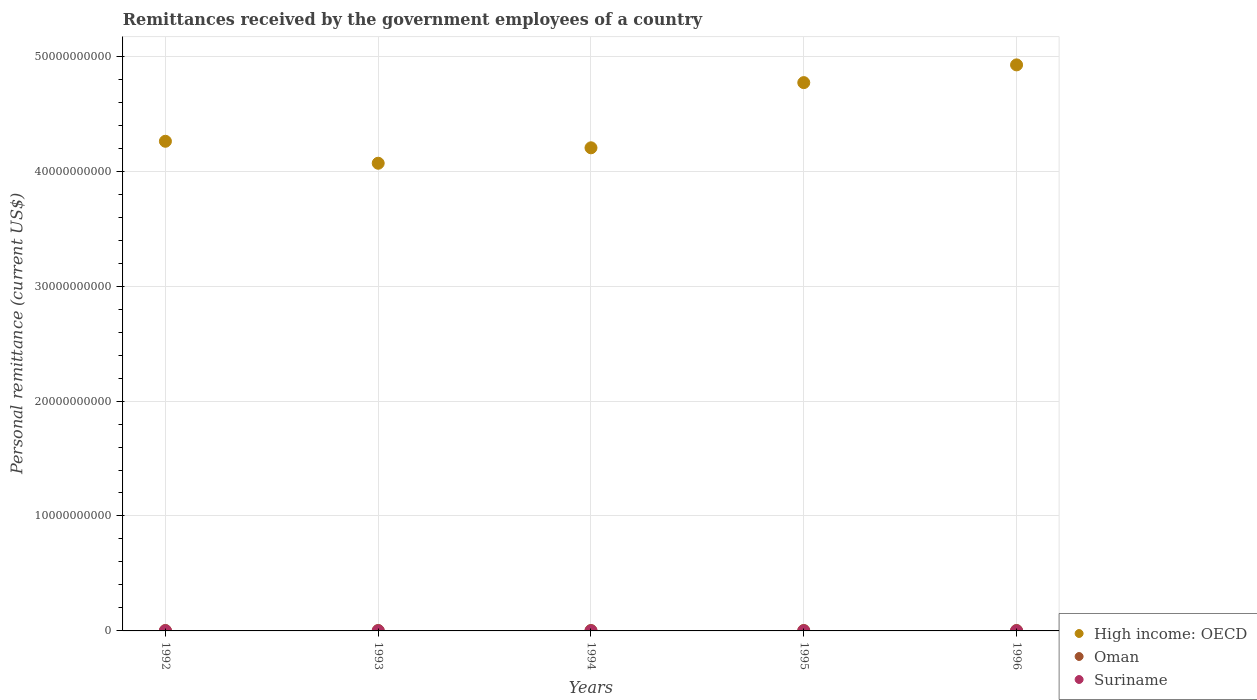Is the number of dotlines equal to the number of legend labels?
Give a very brief answer. Yes. What is the remittances received by the government employees in Suriname in 1993?
Offer a very short reply. 3.50e+06. Across all years, what is the maximum remittances received by the government employees in Oman?
Your answer should be very brief. 3.90e+07. Across all years, what is the minimum remittances received by the government employees in Oman?
Make the answer very short. 3.90e+07. What is the total remittances received by the government employees in Oman in the graph?
Your answer should be compact. 1.95e+08. What is the difference between the remittances received by the government employees in Suriname in 1992 and that in 1996?
Provide a short and direct response. 4.27e+06. What is the difference between the remittances received by the government employees in High income: OECD in 1992 and the remittances received by the government employees in Suriname in 1995?
Offer a very short reply. 4.26e+1. What is the average remittances received by the government employees in Suriname per year?
Provide a short and direct response. 1.78e+06. In the year 1994, what is the difference between the remittances received by the government employees in Oman and remittances received by the government employees in High income: OECD?
Keep it short and to the point. -4.20e+1. What is the ratio of the remittances received by the government employees in High income: OECD in 1993 to that in 1994?
Your answer should be compact. 0.97. Is the remittances received by the government employees in High income: OECD in 1994 less than that in 1995?
Provide a short and direct response. Yes. Is the difference between the remittances received by the government employees in Oman in 1994 and 1996 greater than the difference between the remittances received by the government employees in High income: OECD in 1994 and 1996?
Offer a very short reply. Yes. What is the difference between the highest and the second highest remittances received by the government employees in Suriname?
Provide a succinct answer. 1.10e+06. What is the difference between the highest and the lowest remittances received by the government employees in Oman?
Your response must be concise. 1.17e+04. In how many years, is the remittances received by the government employees in Oman greater than the average remittances received by the government employees in Oman taken over all years?
Provide a succinct answer. 4. Is the sum of the remittances received by the government employees in Oman in 1992 and 1993 greater than the maximum remittances received by the government employees in Suriname across all years?
Offer a terse response. Yes. Does the graph contain grids?
Your response must be concise. Yes. How many legend labels are there?
Make the answer very short. 3. How are the legend labels stacked?
Provide a short and direct response. Vertical. What is the title of the graph?
Your answer should be very brief. Remittances received by the government employees of a country. Does "Montenegro" appear as one of the legend labels in the graph?
Give a very brief answer. No. What is the label or title of the Y-axis?
Give a very brief answer. Personal remittance (current US$). What is the Personal remittance (current US$) in High income: OECD in 1992?
Give a very brief answer. 4.26e+1. What is the Personal remittance (current US$) of Oman in 1992?
Offer a terse response. 3.90e+07. What is the Personal remittance (current US$) of Suriname in 1992?
Your answer should be compact. 4.60e+06. What is the Personal remittance (current US$) in High income: OECD in 1993?
Give a very brief answer. 4.07e+1. What is the Personal remittance (current US$) of Oman in 1993?
Provide a short and direct response. 3.90e+07. What is the Personal remittance (current US$) in Suriname in 1993?
Your response must be concise. 3.50e+06. What is the Personal remittance (current US$) in High income: OECD in 1994?
Your response must be concise. 4.20e+1. What is the Personal remittance (current US$) of Oman in 1994?
Ensure brevity in your answer.  3.90e+07. What is the Personal remittance (current US$) of Suriname in 1994?
Keep it short and to the point. 2.00e+05. What is the Personal remittance (current US$) of High income: OECD in 1995?
Make the answer very short. 4.77e+1. What is the Personal remittance (current US$) of Oman in 1995?
Keep it short and to the point. 3.90e+07. What is the Personal remittance (current US$) in Suriname in 1995?
Ensure brevity in your answer.  2.67e+05. What is the Personal remittance (current US$) of High income: OECD in 1996?
Offer a very short reply. 4.92e+1. What is the Personal remittance (current US$) in Oman in 1996?
Provide a succinct answer. 3.90e+07. What is the Personal remittance (current US$) in Suriname in 1996?
Your answer should be compact. 3.33e+05. Across all years, what is the maximum Personal remittance (current US$) of High income: OECD?
Offer a very short reply. 4.92e+1. Across all years, what is the maximum Personal remittance (current US$) in Oman?
Your answer should be compact. 3.90e+07. Across all years, what is the maximum Personal remittance (current US$) in Suriname?
Provide a short and direct response. 4.60e+06. Across all years, what is the minimum Personal remittance (current US$) in High income: OECD?
Offer a terse response. 4.07e+1. Across all years, what is the minimum Personal remittance (current US$) in Oman?
Your response must be concise. 3.90e+07. Across all years, what is the minimum Personal remittance (current US$) in Suriname?
Offer a very short reply. 2.00e+05. What is the total Personal remittance (current US$) in High income: OECD in the graph?
Give a very brief answer. 2.22e+11. What is the total Personal remittance (current US$) of Oman in the graph?
Provide a short and direct response. 1.95e+08. What is the total Personal remittance (current US$) in Suriname in the graph?
Offer a terse response. 8.90e+06. What is the difference between the Personal remittance (current US$) in High income: OECD in 1992 and that in 1993?
Give a very brief answer. 1.91e+09. What is the difference between the Personal remittance (current US$) in Suriname in 1992 and that in 1993?
Your answer should be very brief. 1.10e+06. What is the difference between the Personal remittance (current US$) in High income: OECD in 1992 and that in 1994?
Ensure brevity in your answer.  5.69e+08. What is the difference between the Personal remittance (current US$) of Oman in 1992 and that in 1994?
Ensure brevity in your answer.  0. What is the difference between the Personal remittance (current US$) of Suriname in 1992 and that in 1994?
Provide a succinct answer. 4.40e+06. What is the difference between the Personal remittance (current US$) in High income: OECD in 1992 and that in 1995?
Keep it short and to the point. -5.10e+09. What is the difference between the Personal remittance (current US$) in Oman in 1992 and that in 1995?
Give a very brief answer. 0. What is the difference between the Personal remittance (current US$) in Suriname in 1992 and that in 1995?
Your answer should be very brief. 4.33e+06. What is the difference between the Personal remittance (current US$) of High income: OECD in 1992 and that in 1996?
Your response must be concise. -6.65e+09. What is the difference between the Personal remittance (current US$) in Oman in 1992 and that in 1996?
Provide a short and direct response. 1.17e+04. What is the difference between the Personal remittance (current US$) in Suriname in 1992 and that in 1996?
Keep it short and to the point. 4.27e+06. What is the difference between the Personal remittance (current US$) of High income: OECD in 1993 and that in 1994?
Your answer should be compact. -1.34e+09. What is the difference between the Personal remittance (current US$) in Suriname in 1993 and that in 1994?
Provide a succinct answer. 3.30e+06. What is the difference between the Personal remittance (current US$) in High income: OECD in 1993 and that in 1995?
Provide a succinct answer. -7.01e+09. What is the difference between the Personal remittance (current US$) in Suriname in 1993 and that in 1995?
Ensure brevity in your answer.  3.23e+06. What is the difference between the Personal remittance (current US$) of High income: OECD in 1993 and that in 1996?
Keep it short and to the point. -8.56e+09. What is the difference between the Personal remittance (current US$) of Oman in 1993 and that in 1996?
Your response must be concise. 1.17e+04. What is the difference between the Personal remittance (current US$) of Suriname in 1993 and that in 1996?
Provide a short and direct response. 3.17e+06. What is the difference between the Personal remittance (current US$) in High income: OECD in 1994 and that in 1995?
Ensure brevity in your answer.  -5.67e+09. What is the difference between the Personal remittance (current US$) of Oman in 1994 and that in 1995?
Offer a terse response. 0. What is the difference between the Personal remittance (current US$) in Suriname in 1994 and that in 1995?
Your answer should be very brief. -6.67e+04. What is the difference between the Personal remittance (current US$) in High income: OECD in 1994 and that in 1996?
Provide a short and direct response. -7.21e+09. What is the difference between the Personal remittance (current US$) of Oman in 1994 and that in 1996?
Make the answer very short. 1.17e+04. What is the difference between the Personal remittance (current US$) of Suriname in 1994 and that in 1996?
Give a very brief answer. -1.33e+05. What is the difference between the Personal remittance (current US$) of High income: OECD in 1995 and that in 1996?
Make the answer very short. -1.54e+09. What is the difference between the Personal remittance (current US$) in Oman in 1995 and that in 1996?
Keep it short and to the point. 1.17e+04. What is the difference between the Personal remittance (current US$) in Suriname in 1995 and that in 1996?
Offer a very short reply. -6.67e+04. What is the difference between the Personal remittance (current US$) in High income: OECD in 1992 and the Personal remittance (current US$) in Oman in 1993?
Your response must be concise. 4.26e+1. What is the difference between the Personal remittance (current US$) in High income: OECD in 1992 and the Personal remittance (current US$) in Suriname in 1993?
Your answer should be compact. 4.26e+1. What is the difference between the Personal remittance (current US$) in Oman in 1992 and the Personal remittance (current US$) in Suriname in 1993?
Offer a very short reply. 3.55e+07. What is the difference between the Personal remittance (current US$) in High income: OECD in 1992 and the Personal remittance (current US$) in Oman in 1994?
Offer a very short reply. 4.26e+1. What is the difference between the Personal remittance (current US$) in High income: OECD in 1992 and the Personal remittance (current US$) in Suriname in 1994?
Offer a very short reply. 4.26e+1. What is the difference between the Personal remittance (current US$) in Oman in 1992 and the Personal remittance (current US$) in Suriname in 1994?
Offer a very short reply. 3.88e+07. What is the difference between the Personal remittance (current US$) of High income: OECD in 1992 and the Personal remittance (current US$) of Oman in 1995?
Ensure brevity in your answer.  4.26e+1. What is the difference between the Personal remittance (current US$) in High income: OECD in 1992 and the Personal remittance (current US$) in Suriname in 1995?
Give a very brief answer. 4.26e+1. What is the difference between the Personal remittance (current US$) in Oman in 1992 and the Personal remittance (current US$) in Suriname in 1995?
Provide a succinct answer. 3.87e+07. What is the difference between the Personal remittance (current US$) of High income: OECD in 1992 and the Personal remittance (current US$) of Oman in 1996?
Ensure brevity in your answer.  4.26e+1. What is the difference between the Personal remittance (current US$) of High income: OECD in 1992 and the Personal remittance (current US$) of Suriname in 1996?
Offer a very short reply. 4.26e+1. What is the difference between the Personal remittance (current US$) in Oman in 1992 and the Personal remittance (current US$) in Suriname in 1996?
Keep it short and to the point. 3.87e+07. What is the difference between the Personal remittance (current US$) in High income: OECD in 1993 and the Personal remittance (current US$) in Oman in 1994?
Offer a terse response. 4.07e+1. What is the difference between the Personal remittance (current US$) in High income: OECD in 1993 and the Personal remittance (current US$) in Suriname in 1994?
Your answer should be very brief. 4.07e+1. What is the difference between the Personal remittance (current US$) of Oman in 1993 and the Personal remittance (current US$) of Suriname in 1994?
Provide a succinct answer. 3.88e+07. What is the difference between the Personal remittance (current US$) of High income: OECD in 1993 and the Personal remittance (current US$) of Oman in 1995?
Your answer should be very brief. 4.07e+1. What is the difference between the Personal remittance (current US$) of High income: OECD in 1993 and the Personal remittance (current US$) of Suriname in 1995?
Offer a terse response. 4.07e+1. What is the difference between the Personal remittance (current US$) of Oman in 1993 and the Personal remittance (current US$) of Suriname in 1995?
Ensure brevity in your answer.  3.87e+07. What is the difference between the Personal remittance (current US$) in High income: OECD in 1993 and the Personal remittance (current US$) in Oman in 1996?
Your answer should be very brief. 4.07e+1. What is the difference between the Personal remittance (current US$) of High income: OECD in 1993 and the Personal remittance (current US$) of Suriname in 1996?
Offer a terse response. 4.07e+1. What is the difference between the Personal remittance (current US$) of Oman in 1993 and the Personal remittance (current US$) of Suriname in 1996?
Your answer should be compact. 3.87e+07. What is the difference between the Personal remittance (current US$) in High income: OECD in 1994 and the Personal remittance (current US$) in Oman in 1995?
Provide a short and direct response. 4.20e+1. What is the difference between the Personal remittance (current US$) in High income: OECD in 1994 and the Personal remittance (current US$) in Suriname in 1995?
Offer a very short reply. 4.20e+1. What is the difference between the Personal remittance (current US$) of Oman in 1994 and the Personal remittance (current US$) of Suriname in 1995?
Keep it short and to the point. 3.87e+07. What is the difference between the Personal remittance (current US$) of High income: OECD in 1994 and the Personal remittance (current US$) of Oman in 1996?
Ensure brevity in your answer.  4.20e+1. What is the difference between the Personal remittance (current US$) of High income: OECD in 1994 and the Personal remittance (current US$) of Suriname in 1996?
Offer a terse response. 4.20e+1. What is the difference between the Personal remittance (current US$) of Oman in 1994 and the Personal remittance (current US$) of Suriname in 1996?
Make the answer very short. 3.87e+07. What is the difference between the Personal remittance (current US$) of High income: OECD in 1995 and the Personal remittance (current US$) of Oman in 1996?
Offer a terse response. 4.77e+1. What is the difference between the Personal remittance (current US$) of High income: OECD in 1995 and the Personal remittance (current US$) of Suriname in 1996?
Make the answer very short. 4.77e+1. What is the difference between the Personal remittance (current US$) in Oman in 1995 and the Personal remittance (current US$) in Suriname in 1996?
Keep it short and to the point. 3.87e+07. What is the average Personal remittance (current US$) of High income: OECD per year?
Your response must be concise. 4.45e+1. What is the average Personal remittance (current US$) in Oman per year?
Provide a short and direct response. 3.90e+07. What is the average Personal remittance (current US$) of Suriname per year?
Your answer should be very brief. 1.78e+06. In the year 1992, what is the difference between the Personal remittance (current US$) of High income: OECD and Personal remittance (current US$) of Oman?
Your response must be concise. 4.26e+1. In the year 1992, what is the difference between the Personal remittance (current US$) in High income: OECD and Personal remittance (current US$) in Suriname?
Your response must be concise. 4.26e+1. In the year 1992, what is the difference between the Personal remittance (current US$) in Oman and Personal remittance (current US$) in Suriname?
Provide a succinct answer. 3.44e+07. In the year 1993, what is the difference between the Personal remittance (current US$) in High income: OECD and Personal remittance (current US$) in Oman?
Your answer should be very brief. 4.07e+1. In the year 1993, what is the difference between the Personal remittance (current US$) in High income: OECD and Personal remittance (current US$) in Suriname?
Your answer should be compact. 4.07e+1. In the year 1993, what is the difference between the Personal remittance (current US$) in Oman and Personal remittance (current US$) in Suriname?
Give a very brief answer. 3.55e+07. In the year 1994, what is the difference between the Personal remittance (current US$) of High income: OECD and Personal remittance (current US$) of Oman?
Ensure brevity in your answer.  4.20e+1. In the year 1994, what is the difference between the Personal remittance (current US$) of High income: OECD and Personal remittance (current US$) of Suriname?
Offer a very short reply. 4.20e+1. In the year 1994, what is the difference between the Personal remittance (current US$) of Oman and Personal remittance (current US$) of Suriname?
Your response must be concise. 3.88e+07. In the year 1995, what is the difference between the Personal remittance (current US$) of High income: OECD and Personal remittance (current US$) of Oman?
Offer a terse response. 4.77e+1. In the year 1995, what is the difference between the Personal remittance (current US$) of High income: OECD and Personal remittance (current US$) of Suriname?
Your answer should be very brief. 4.77e+1. In the year 1995, what is the difference between the Personal remittance (current US$) of Oman and Personal remittance (current US$) of Suriname?
Your response must be concise. 3.87e+07. In the year 1996, what is the difference between the Personal remittance (current US$) of High income: OECD and Personal remittance (current US$) of Oman?
Provide a succinct answer. 4.92e+1. In the year 1996, what is the difference between the Personal remittance (current US$) of High income: OECD and Personal remittance (current US$) of Suriname?
Ensure brevity in your answer.  4.92e+1. In the year 1996, what is the difference between the Personal remittance (current US$) in Oman and Personal remittance (current US$) in Suriname?
Provide a succinct answer. 3.87e+07. What is the ratio of the Personal remittance (current US$) in High income: OECD in 1992 to that in 1993?
Ensure brevity in your answer.  1.05. What is the ratio of the Personal remittance (current US$) in Suriname in 1992 to that in 1993?
Make the answer very short. 1.31. What is the ratio of the Personal remittance (current US$) in High income: OECD in 1992 to that in 1994?
Offer a terse response. 1.01. What is the ratio of the Personal remittance (current US$) of High income: OECD in 1992 to that in 1995?
Ensure brevity in your answer.  0.89. What is the ratio of the Personal remittance (current US$) of Oman in 1992 to that in 1995?
Make the answer very short. 1. What is the ratio of the Personal remittance (current US$) of Suriname in 1992 to that in 1995?
Make the answer very short. 17.25. What is the ratio of the Personal remittance (current US$) in High income: OECD in 1992 to that in 1996?
Offer a very short reply. 0.86. What is the ratio of the Personal remittance (current US$) in Oman in 1992 to that in 1996?
Your answer should be very brief. 1. What is the ratio of the Personal remittance (current US$) of Suriname in 1992 to that in 1996?
Provide a short and direct response. 13.8. What is the ratio of the Personal remittance (current US$) of High income: OECD in 1993 to that in 1994?
Provide a short and direct response. 0.97. What is the ratio of the Personal remittance (current US$) of Oman in 1993 to that in 1994?
Offer a very short reply. 1. What is the ratio of the Personal remittance (current US$) in Suriname in 1993 to that in 1994?
Your answer should be very brief. 17.5. What is the ratio of the Personal remittance (current US$) in High income: OECD in 1993 to that in 1995?
Give a very brief answer. 0.85. What is the ratio of the Personal remittance (current US$) in Suriname in 1993 to that in 1995?
Ensure brevity in your answer.  13.12. What is the ratio of the Personal remittance (current US$) of High income: OECD in 1993 to that in 1996?
Your response must be concise. 0.83. What is the ratio of the Personal remittance (current US$) in High income: OECD in 1994 to that in 1995?
Your answer should be very brief. 0.88. What is the ratio of the Personal remittance (current US$) in Oman in 1994 to that in 1995?
Ensure brevity in your answer.  1. What is the ratio of the Personal remittance (current US$) of High income: OECD in 1994 to that in 1996?
Offer a very short reply. 0.85. What is the ratio of the Personal remittance (current US$) in High income: OECD in 1995 to that in 1996?
Offer a terse response. 0.97. What is the ratio of the Personal remittance (current US$) in Oman in 1995 to that in 1996?
Provide a succinct answer. 1. What is the difference between the highest and the second highest Personal remittance (current US$) in High income: OECD?
Offer a terse response. 1.54e+09. What is the difference between the highest and the second highest Personal remittance (current US$) of Suriname?
Your response must be concise. 1.10e+06. What is the difference between the highest and the lowest Personal remittance (current US$) of High income: OECD?
Provide a succinct answer. 8.56e+09. What is the difference between the highest and the lowest Personal remittance (current US$) of Oman?
Provide a succinct answer. 1.17e+04. What is the difference between the highest and the lowest Personal remittance (current US$) in Suriname?
Keep it short and to the point. 4.40e+06. 